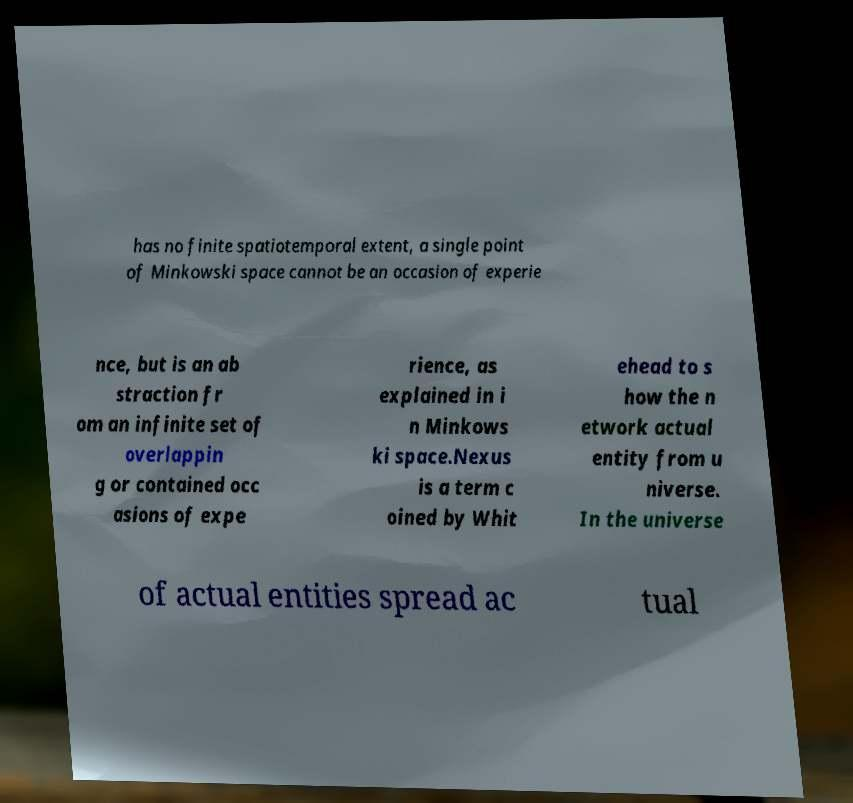I need the written content from this picture converted into text. Can you do that? has no finite spatiotemporal extent, a single point of Minkowski space cannot be an occasion of experie nce, but is an ab straction fr om an infinite set of overlappin g or contained occ asions of expe rience, as explained in i n Minkows ki space.Nexus is a term c oined by Whit ehead to s how the n etwork actual entity from u niverse. In the universe of actual entities spread ac tual 